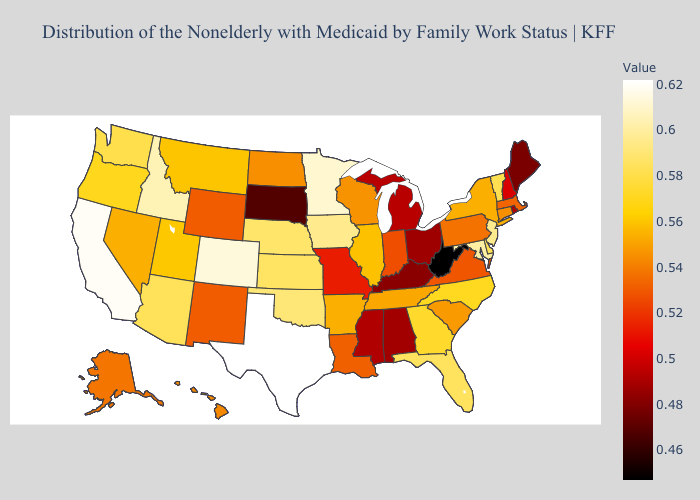Does Arkansas have the highest value in the USA?
Short answer required. No. Among the states that border Idaho , does Oregon have the highest value?
Answer briefly. No. Among the states that border Montana , does South Dakota have the highest value?
Be succinct. No. Among the states that border Arizona , does New Mexico have the lowest value?
Quick response, please. Yes. Does Alaska have the highest value in the West?
Quick response, please. No. Which states hav the highest value in the MidWest?
Short answer required. Minnesota. Is the legend a continuous bar?
Write a very short answer. Yes. Does Texas have the highest value in the USA?
Be succinct. Yes. Does Louisiana have the lowest value in the USA?
Answer briefly. No. Which states have the lowest value in the West?
Answer briefly. New Mexico, Wyoming. Which states have the lowest value in the MidWest?
Be succinct. South Dakota. 